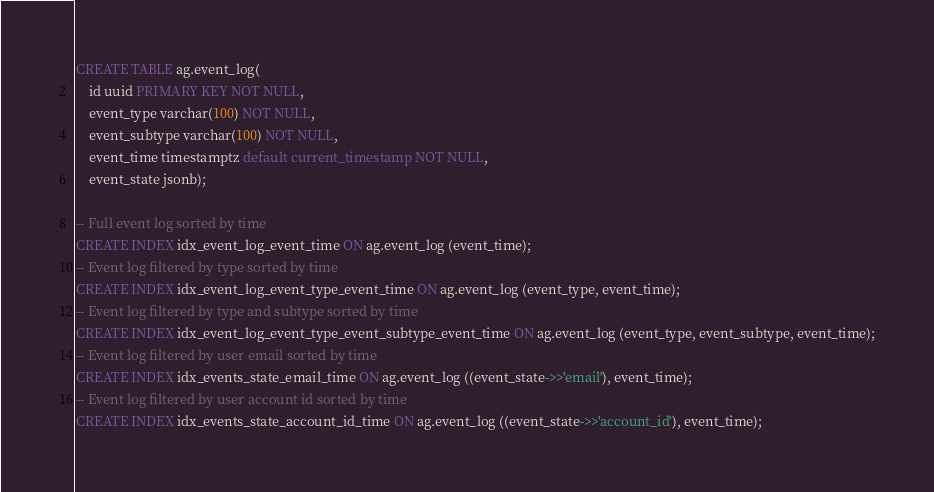<code> <loc_0><loc_0><loc_500><loc_500><_SQL_>CREATE TABLE ag.event_log(
    id uuid PRIMARY KEY NOT NULL,
    event_type varchar(100) NOT NULL,
    event_subtype varchar(100) NOT NULL,
    event_time timestamptz default current_timestamp NOT NULL,
    event_state jsonb);

-- Full event log sorted by time
CREATE INDEX idx_event_log_event_time ON ag.event_log (event_time);
-- Event log filtered by type sorted by time
CREATE INDEX idx_event_log_event_type_event_time ON ag.event_log (event_type, event_time);
-- Event log filtered by type and subtype sorted by time
CREATE INDEX idx_event_log_event_type_event_subtype_event_time ON ag.event_log (event_type, event_subtype, event_time);
-- Event log filtered by user email sorted by time
CREATE INDEX idx_events_state_email_time ON ag.event_log ((event_state->>'email'), event_time);
-- Event log filtered by user account id sorted by time
CREATE INDEX idx_events_state_account_id_time ON ag.event_log ((event_state->>'account_id'), event_time);
</code> 